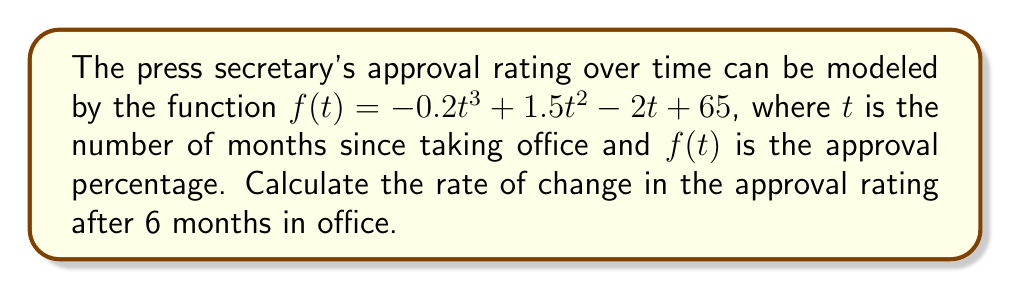Can you answer this question? To find the rate of change in the approval rating, we need to calculate the derivative of the given function and evaluate it at $t = 6$.

1. The given function is $f(t) = -0.2t^3 + 1.5t^2 - 2t + 65$

2. To find the derivative, we apply the power rule and constant rule:
   $$f'(t) = (-0.2 \cdot 3)t^2 + (1.5 \cdot 2)t - 2$$
   $$f'(t) = -0.6t^2 + 3t - 2$$

3. Now we evaluate $f'(t)$ at $t = 6$:
   $$f'(6) = -0.6(6)^2 + 3(6) - 2$$
   $$f'(6) = -0.6(36) + 18 - 2$$
   $$f'(6) = -21.6 + 18 - 2$$
   $$f'(6) = -5.6$$

The rate of change is the value of the derivative at the given point. In this case, it's -5.6 percentage points per month.
Answer: $-5.6$ percentage points per month 